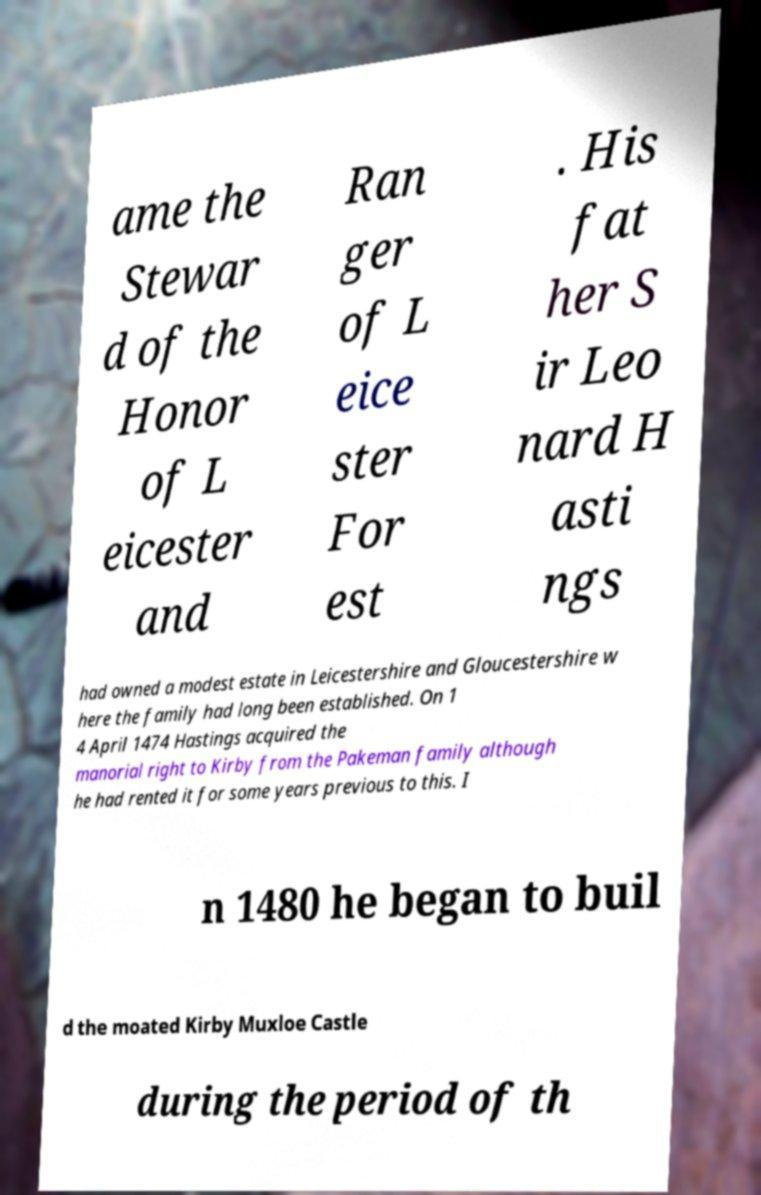Could you assist in decoding the text presented in this image and type it out clearly? ame the Stewar d of the Honor of L eicester and Ran ger of L eice ster For est . His fat her S ir Leo nard H asti ngs had owned a modest estate in Leicestershire and Gloucestershire w here the family had long been established. On 1 4 April 1474 Hastings acquired the manorial right to Kirby from the Pakeman family although he had rented it for some years previous to this. I n 1480 he began to buil d the moated Kirby Muxloe Castle during the period of th 